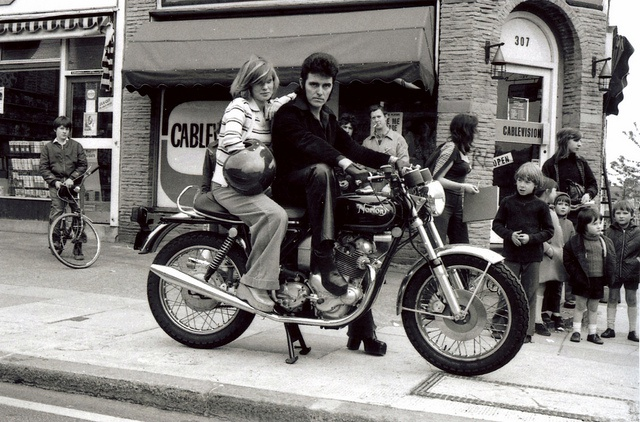Describe the objects in this image and their specific colors. I can see motorcycle in darkgray, black, gray, and lightgray tones, people in darkgray, gray, black, and lightgray tones, people in darkgray, black, and gray tones, people in darkgray, black, gray, and lightgray tones, and people in darkgray, black, gray, and lightgray tones in this image. 